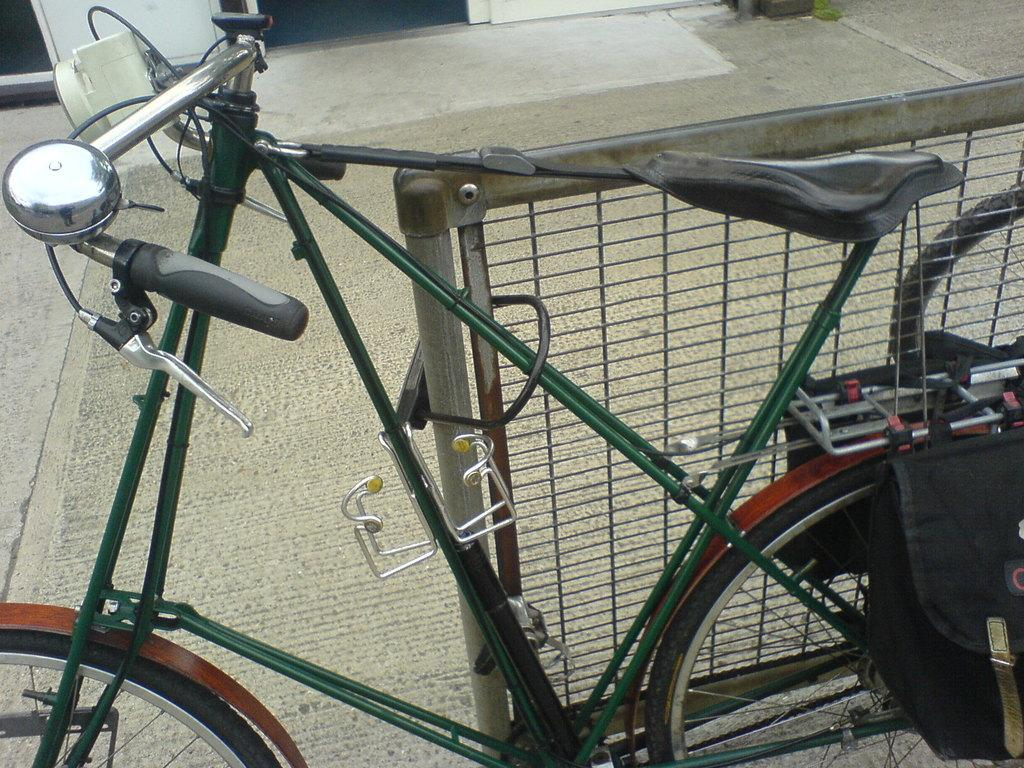What is the surface that can be seen in the image? There is a floor in the image. What mode of transportation is present in the image? There is a bicycle in the image. What item might be used for carrying belongings in the image? There is a bag in the image. What type of barrier can be seen in the image? There is a fence in the image. Can you describe any other objects that are visible in the image? There are some unspecified objects in the image. What type of cork can be seen in the image? There is no cork present in the image. What story is being told by the objects in the image? The objects in the image do not tell a story; they are simply depicted as they are. 